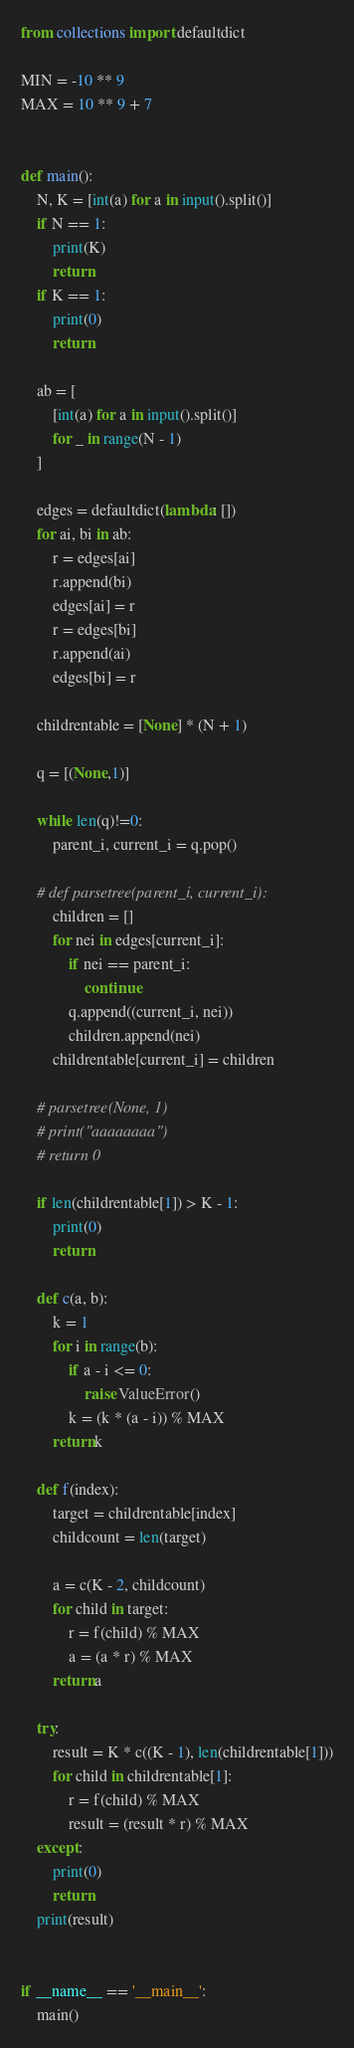<code> <loc_0><loc_0><loc_500><loc_500><_Python_>from collections import defaultdict

MIN = -10 ** 9
MAX = 10 ** 9 + 7


def main():
    N, K = [int(a) for a in input().split()]
    if N == 1:
        print(K)
        return
    if K == 1:
        print(0)
        return

    ab = [
        [int(a) for a in input().split()]
        for _ in range(N - 1)
    ]

    edges = defaultdict(lambda: [])
    for ai, bi in ab:
        r = edges[ai]
        r.append(bi)
        edges[ai] = r
        r = edges[bi]
        r.append(ai)
        edges[bi] = r

    childrentable = [None] * (N + 1)

    q = [(None,1)]

    while len(q)!=0:
        parent_i, current_i = q.pop()

    # def parsetree(parent_i, current_i):
        children = []
        for nei in edges[current_i]:
            if nei == parent_i:
                continue
            q.append((current_i, nei))
            children.append(nei)
        childrentable[current_i] = children

    # parsetree(None, 1)
    # print("aaaaaaaa")
    # return 0

    if len(childrentable[1]) > K - 1:
        print(0)
        return

    def c(a, b):
        k = 1
        for i in range(b):
            if a - i <= 0:
                raise ValueError()
            k = (k * (a - i)) % MAX
        return k

    def f(index):
        target = childrentable[index]
        childcount = len(target)

        a = c(K - 2, childcount)
        for child in target:
            r = f(child) % MAX
            a = (a * r) % MAX
        return a

    try:
        result = K * c((K - 1), len(childrentable[1]))
        for child in childrentable[1]:
            r = f(child) % MAX
            result = (result * r) % MAX
    except:
        print(0)
        return
    print(result)


if __name__ == '__main__':
    main()
</code> 